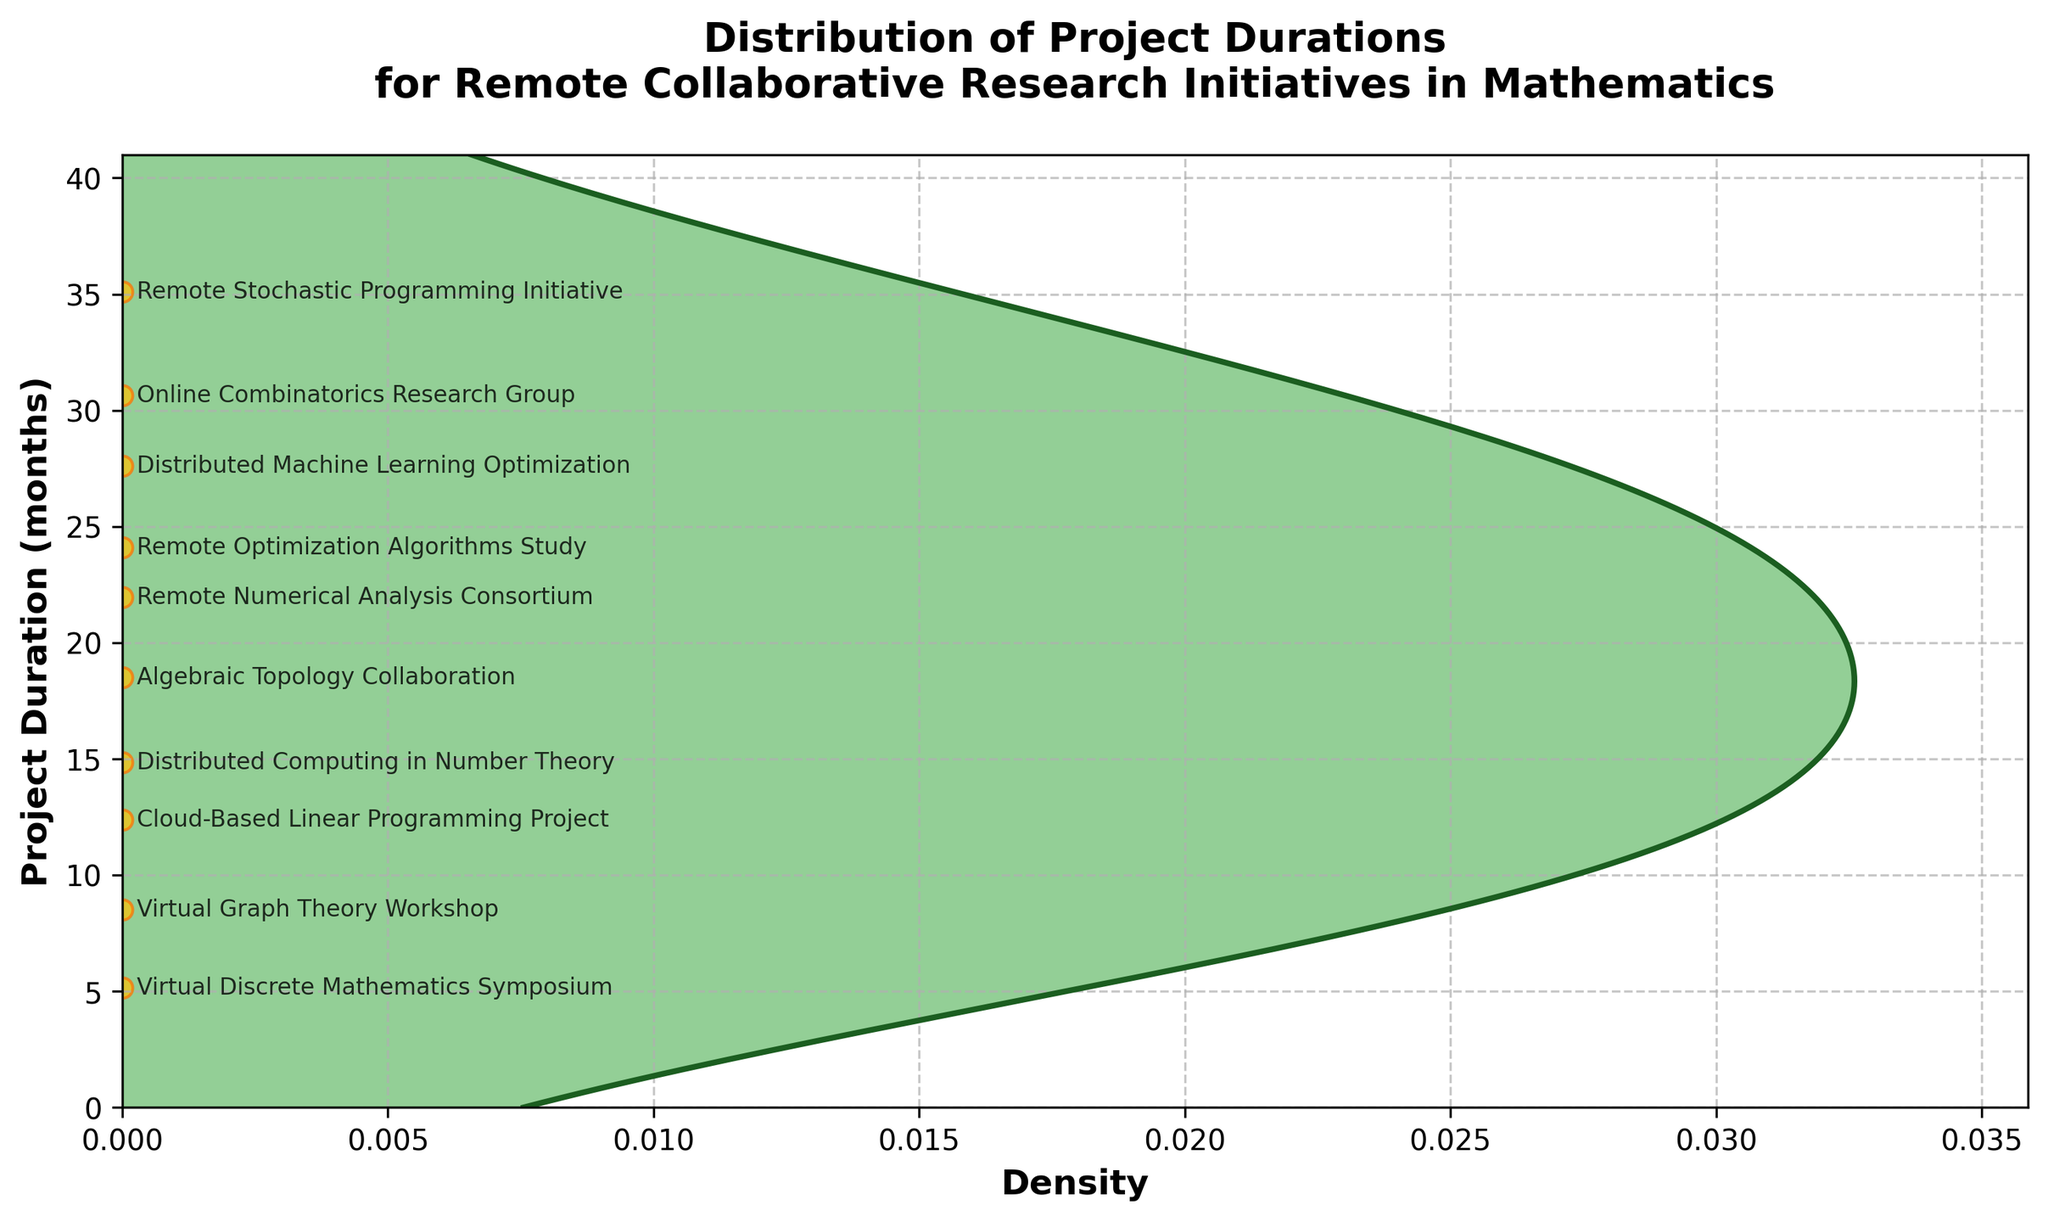What's the title of the figure? The title is located at the top of the figure and can be directly read from this position.
Answer: Distribution of Project Durations for Remote Collaborative Research Initiatives in Mathematics How many projects have a duration of more than 20 months? By examining the y-axis, locate the project durations and count the corresponding points that fall above the 20-month mark.
Answer: 4 What is the duration of the "Remote Optimization Algorithms Study"? Find the annotation labeled "Remote Optimization Algorithms Study" and observe its position on the y-axis.
Answer: 24 months Which project has the shortest duration? Identify the lowest annotation on the y-axis to find the project with the smallest duration.
Answer: Virtual Discrete Mathematics Symposium What is the range of project durations? Calculate the difference between the largest and smallest durations by examining the y-axis.
Answer: 36 - 6 = 30 months Which project is closer in duration to the average, "Distributed Computing in Number Theory" or "Distributed Machine Learning Optimization"? Compute the average of all project durations and compare the proximity of the durations of the two specified projects to this average. Average = (18+24+15+9+30+12+21+27+6+36) / 10 = 19.8 months
Answer: Distributed Computing in Number Theory What is the peak density value for the project durations? Observe the highest point on the density plot along the x-axis.
Answer: Around 0.03 How does the duration of the "Online Combinatorics Research Group" compare to the median project duration? Determine the median duration by sorting the durations and finding the middle value, then compare it to the specified project's duration. Sorted durations: [6, 9, 12, 15, 18, 21, 24, 27, 30, 36], Median = 19.5 months
Answer: Longer Are there more projects with durations below 20 months or above 20 months? Count the number of projects whose durations are below and above 20 months from the scatter plot. Below: 6, 9, 12, 15, 18, Above: 21, 24, 27, 30, 36
Answer: More below Is there any indication of bimodality in the density distribution? Observing the density plot for multiple peaks can help determine if the distribution is bimodal.
Answer: No, the plot shows a single peak 